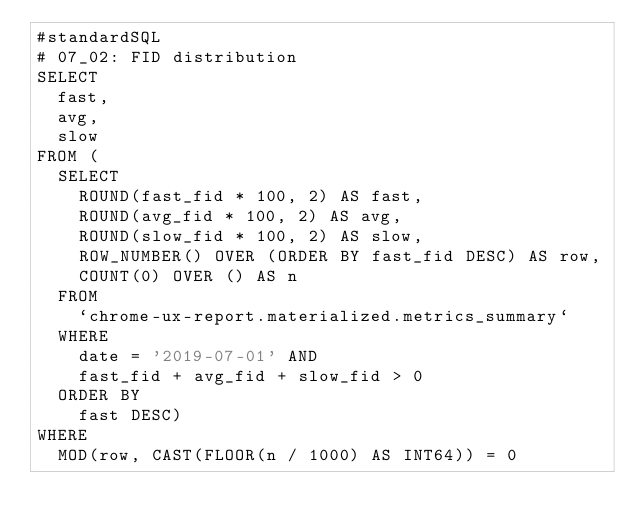Convert code to text. <code><loc_0><loc_0><loc_500><loc_500><_SQL_>#standardSQL
# 07_02: FID distribution
SELECT
  fast,
  avg,
  slow
FROM (
  SELECT
    ROUND(fast_fid * 100, 2) AS fast,
    ROUND(avg_fid * 100, 2) AS avg,
    ROUND(slow_fid * 100, 2) AS slow,
    ROW_NUMBER() OVER (ORDER BY fast_fid DESC) AS row,
    COUNT(0) OVER () AS n
  FROM
    `chrome-ux-report.materialized.metrics_summary`
  WHERE
    date = '2019-07-01' AND
    fast_fid + avg_fid + slow_fid > 0
  ORDER BY
    fast DESC)
WHERE
  MOD(row, CAST(FLOOR(n / 1000) AS INT64)) = 0</code> 